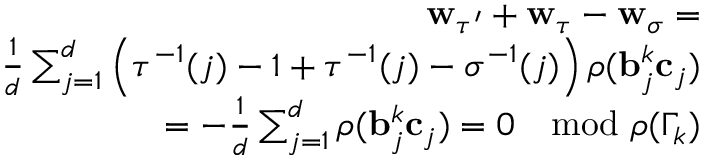<formula> <loc_0><loc_0><loc_500><loc_500>\begin{array} { r } { w _ { \tau ^ { \prime } } + w _ { \tau } - w _ { \sigma } = } \\ { \frac { 1 } { d } \sum _ { j = 1 } ^ { d } \left ( \tau ^ { - 1 } ( j ) - 1 + \tau ^ { - 1 } ( j ) - \sigma ^ { - 1 } ( j ) \right ) \rho ( b _ { j } ^ { k } c _ { j } ) } \\ { = - \frac { 1 } { d } \sum _ { j = 1 } ^ { d } \rho ( b _ { j } ^ { k } c _ { j } ) = 0 \mod \rho ( \Gamma _ { k } ) } \end{array}</formula> 